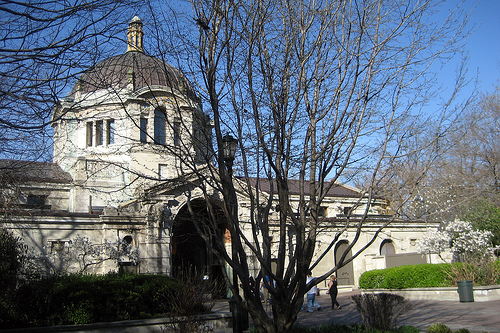<image>
Is the tree under the building? No. The tree is not positioned under the building. The vertical relationship between these objects is different. 